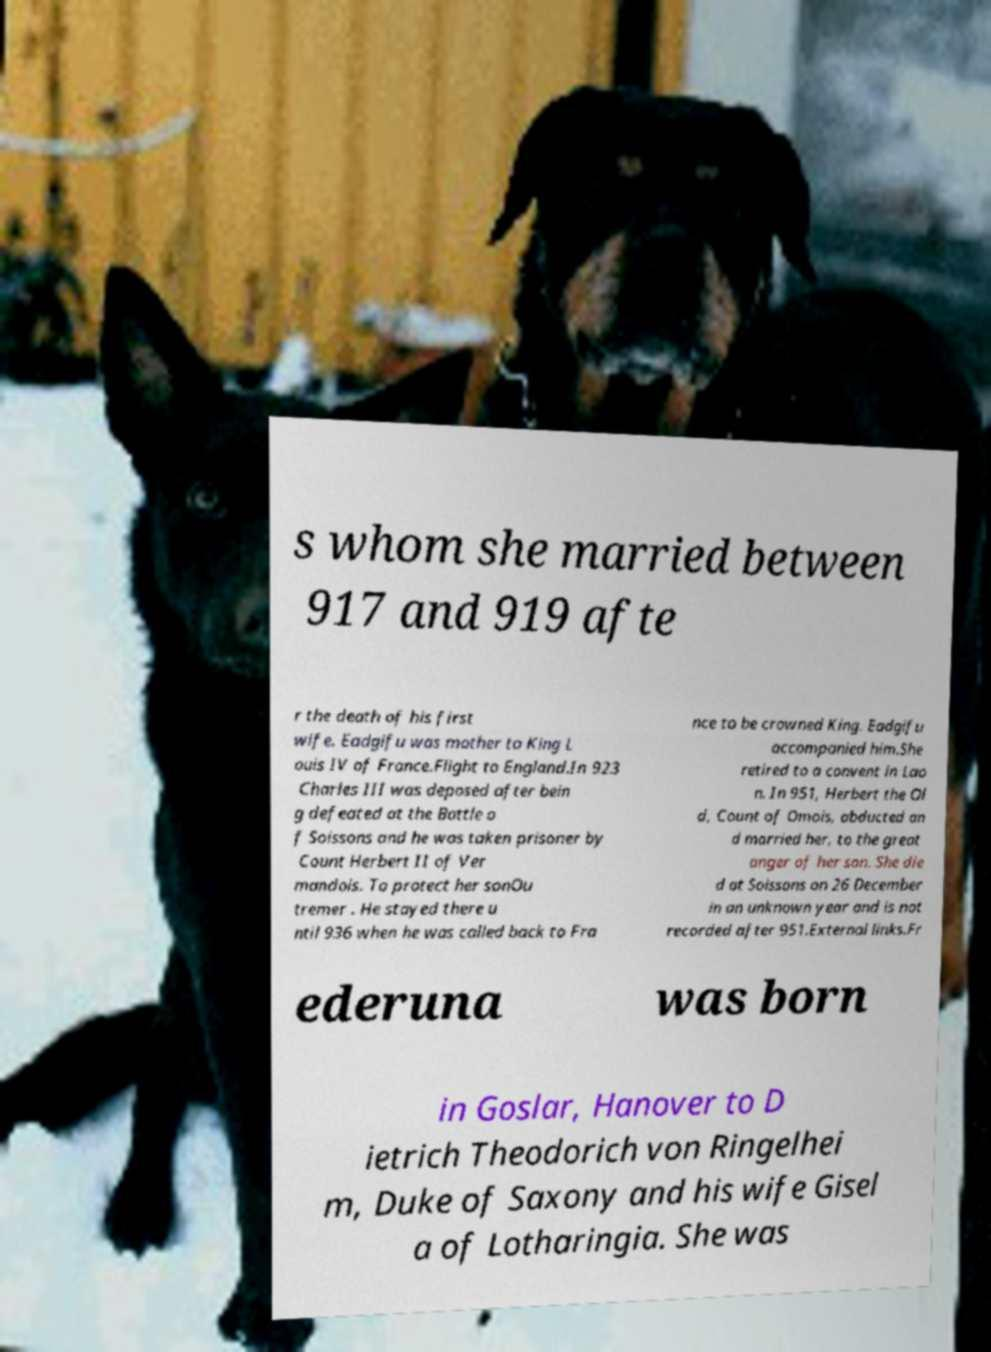Please identify and transcribe the text found in this image. s whom she married between 917 and 919 afte r the death of his first wife. Eadgifu was mother to King L ouis IV of France.Flight to England.In 923 Charles III was deposed after bein g defeated at the Battle o f Soissons and he was taken prisoner by Count Herbert II of Ver mandois. To protect her sonOu tremer . He stayed there u ntil 936 when he was called back to Fra nce to be crowned King. Eadgifu accompanied him.She retired to a convent in Lao n. In 951, Herbert the Ol d, Count of Omois, abducted an d married her, to the great anger of her son. She die d at Soissons on 26 December in an unknown year and is not recorded after 951.External links.Fr ederuna was born in Goslar, Hanover to D ietrich Theodorich von Ringelhei m, Duke of Saxony and his wife Gisel a of Lotharingia. She was 